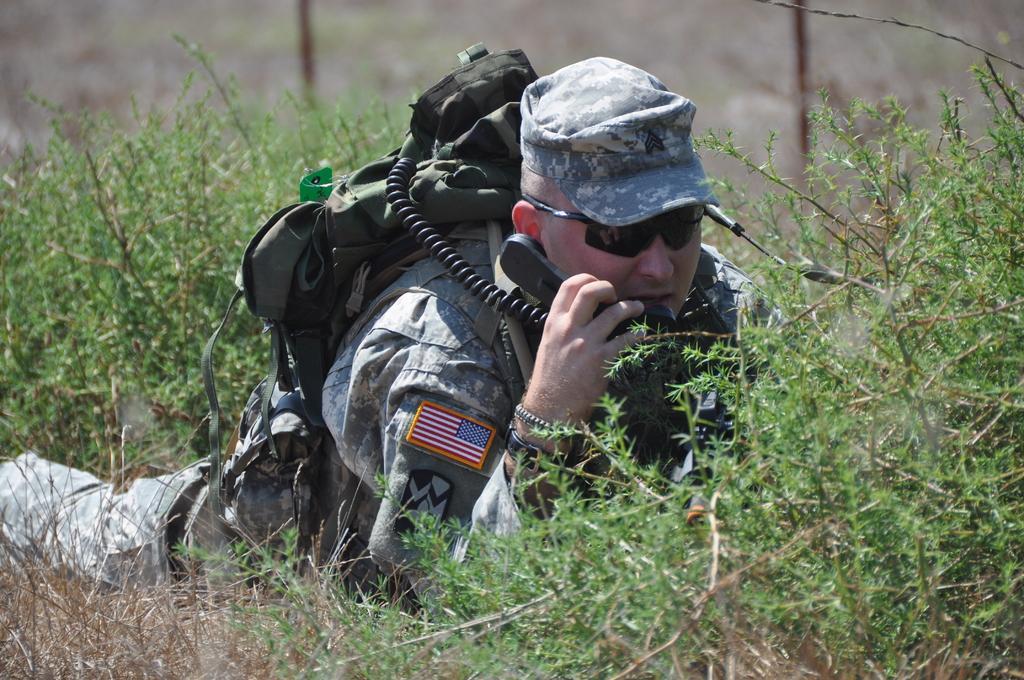Describe this image in one or two sentences. In this picture we can see a man is lying, he is carrying a backpack and holding a telephone, at the bottom there are some plants, we can see a blurry background. 